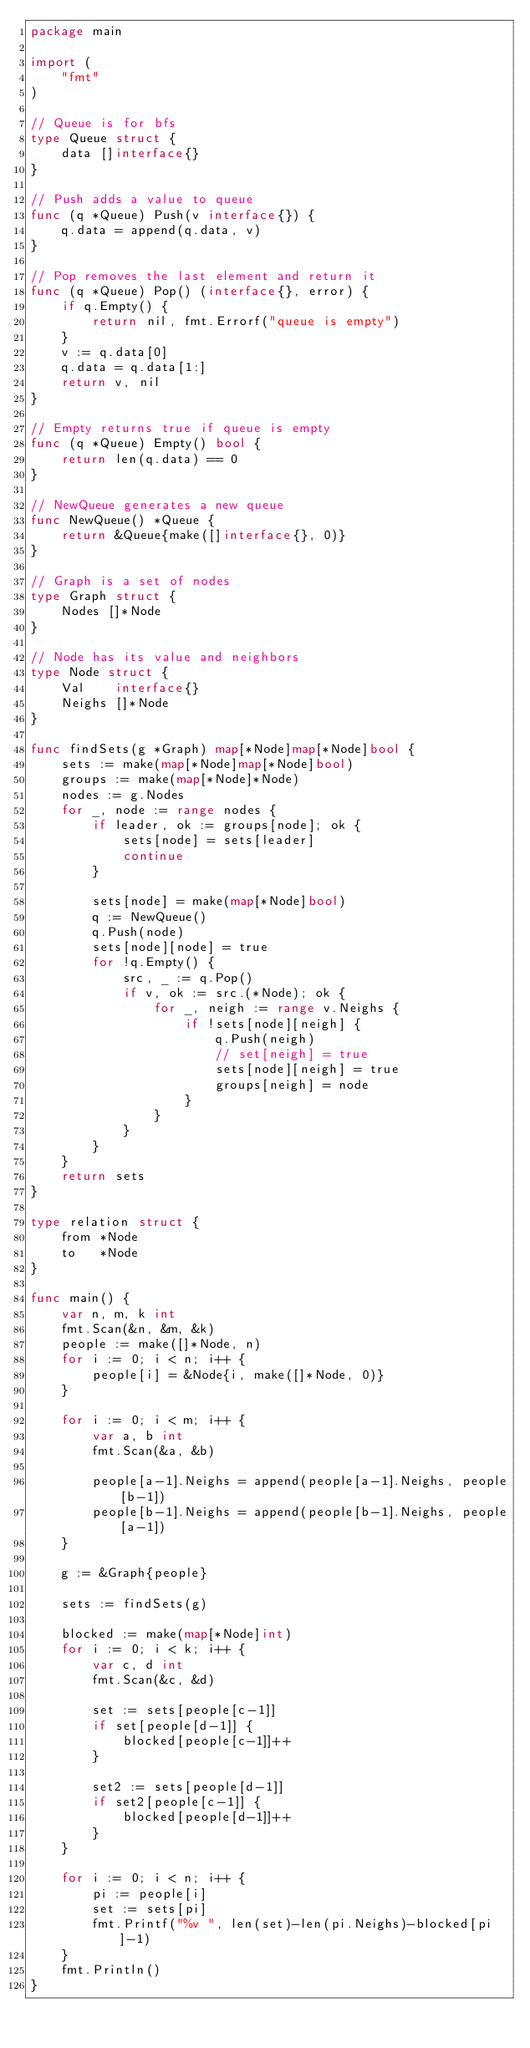<code> <loc_0><loc_0><loc_500><loc_500><_Go_>package main

import (
	"fmt"
)

// Queue is for bfs
type Queue struct {
	data []interface{}
}

// Push adds a value to queue
func (q *Queue) Push(v interface{}) {
	q.data = append(q.data, v)
}

// Pop removes the last element and return it
func (q *Queue) Pop() (interface{}, error) {
	if q.Empty() {
		return nil, fmt.Errorf("queue is empty")
	}
	v := q.data[0]
	q.data = q.data[1:]
	return v, nil
}

// Empty returns true if queue is empty
func (q *Queue) Empty() bool {
	return len(q.data) == 0
}

// NewQueue generates a new queue
func NewQueue() *Queue {
	return &Queue{make([]interface{}, 0)}
}

// Graph is a set of nodes
type Graph struct {
	Nodes []*Node
}

// Node has its value and neighbors
type Node struct {
	Val    interface{}
	Neighs []*Node
}

func findSets(g *Graph) map[*Node]map[*Node]bool {
	sets := make(map[*Node]map[*Node]bool)
	groups := make(map[*Node]*Node)
	nodes := g.Nodes
	for _, node := range nodes {
		if leader, ok := groups[node]; ok {
			sets[node] = sets[leader]
			continue
		}

		sets[node] = make(map[*Node]bool)
		q := NewQueue()
		q.Push(node)
		sets[node][node] = true
		for !q.Empty() {
			src, _ := q.Pop()
			if v, ok := src.(*Node); ok {
				for _, neigh := range v.Neighs {
					if !sets[node][neigh] {
						q.Push(neigh)
						// set[neigh] = true
						sets[node][neigh] = true
						groups[neigh] = node
					}
				}
			}
		}
	}
	return sets
}

type relation struct {
	from *Node
	to   *Node
}

func main() {
	var n, m, k int
	fmt.Scan(&n, &m, &k)
	people := make([]*Node, n)
	for i := 0; i < n; i++ {
		people[i] = &Node{i, make([]*Node, 0)}
	}

	for i := 0; i < m; i++ {
		var a, b int
		fmt.Scan(&a, &b)

		people[a-1].Neighs = append(people[a-1].Neighs, people[b-1])
		people[b-1].Neighs = append(people[b-1].Neighs, people[a-1])
	}

	g := &Graph{people}

	sets := findSets(g)

	blocked := make(map[*Node]int)
	for i := 0; i < k; i++ {
		var c, d int
		fmt.Scan(&c, &d)

		set := sets[people[c-1]]
		if set[people[d-1]] {
			blocked[people[c-1]]++
		}

		set2 := sets[people[d-1]]
		if set2[people[c-1]] {
			blocked[people[d-1]]++
		}
	}

	for i := 0; i < n; i++ {
		pi := people[i]
		set := sets[pi]
		fmt.Printf("%v ", len(set)-len(pi.Neighs)-blocked[pi]-1)
	}
	fmt.Println()
}
</code> 